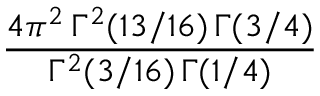Convert formula to latex. <formula><loc_0><loc_0><loc_500><loc_500>{ \frac { 4 \pi ^ { 2 } \, \Gamma ^ { 2 } ( 1 3 / 1 6 ) \, \Gamma ( 3 / 4 ) } { \Gamma ^ { 2 } ( 3 / 1 6 ) \, \Gamma ( 1 / 4 ) } }</formula> 